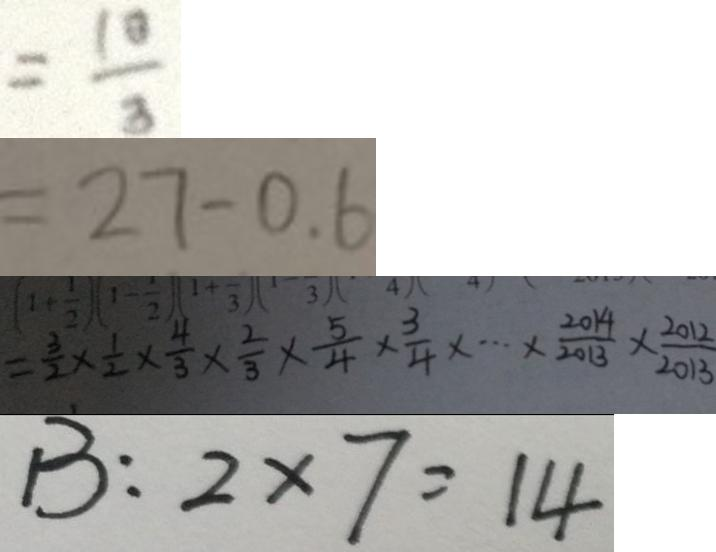Convert formula to latex. <formula><loc_0><loc_0><loc_500><loc_500>= \frac { 1 0 } { 3 } 
 = 2 7 - 0 . 6 
 = \frac { 3 } { 2 } \times \frac { 1 } { 2 } \times \frac { 4 } { 3 } \times \frac { 2 } { 3 } \times \frac { 5 } { 4 } \times \frac { 3 } { 4 } \times \cdots \times \frac { 2 0 1 4 } { 2 0 1 3 } \times \frac { 2 0 1 2 } { 2 0 1 3 } 
 B : 2 \times 7 = 1 4</formula> 